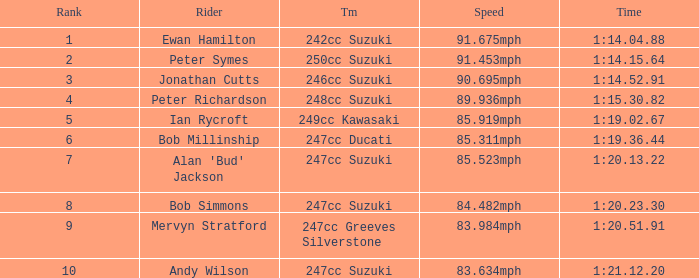What was the speed for the rider with a time of 1:14.15.64? 91.453mph. 